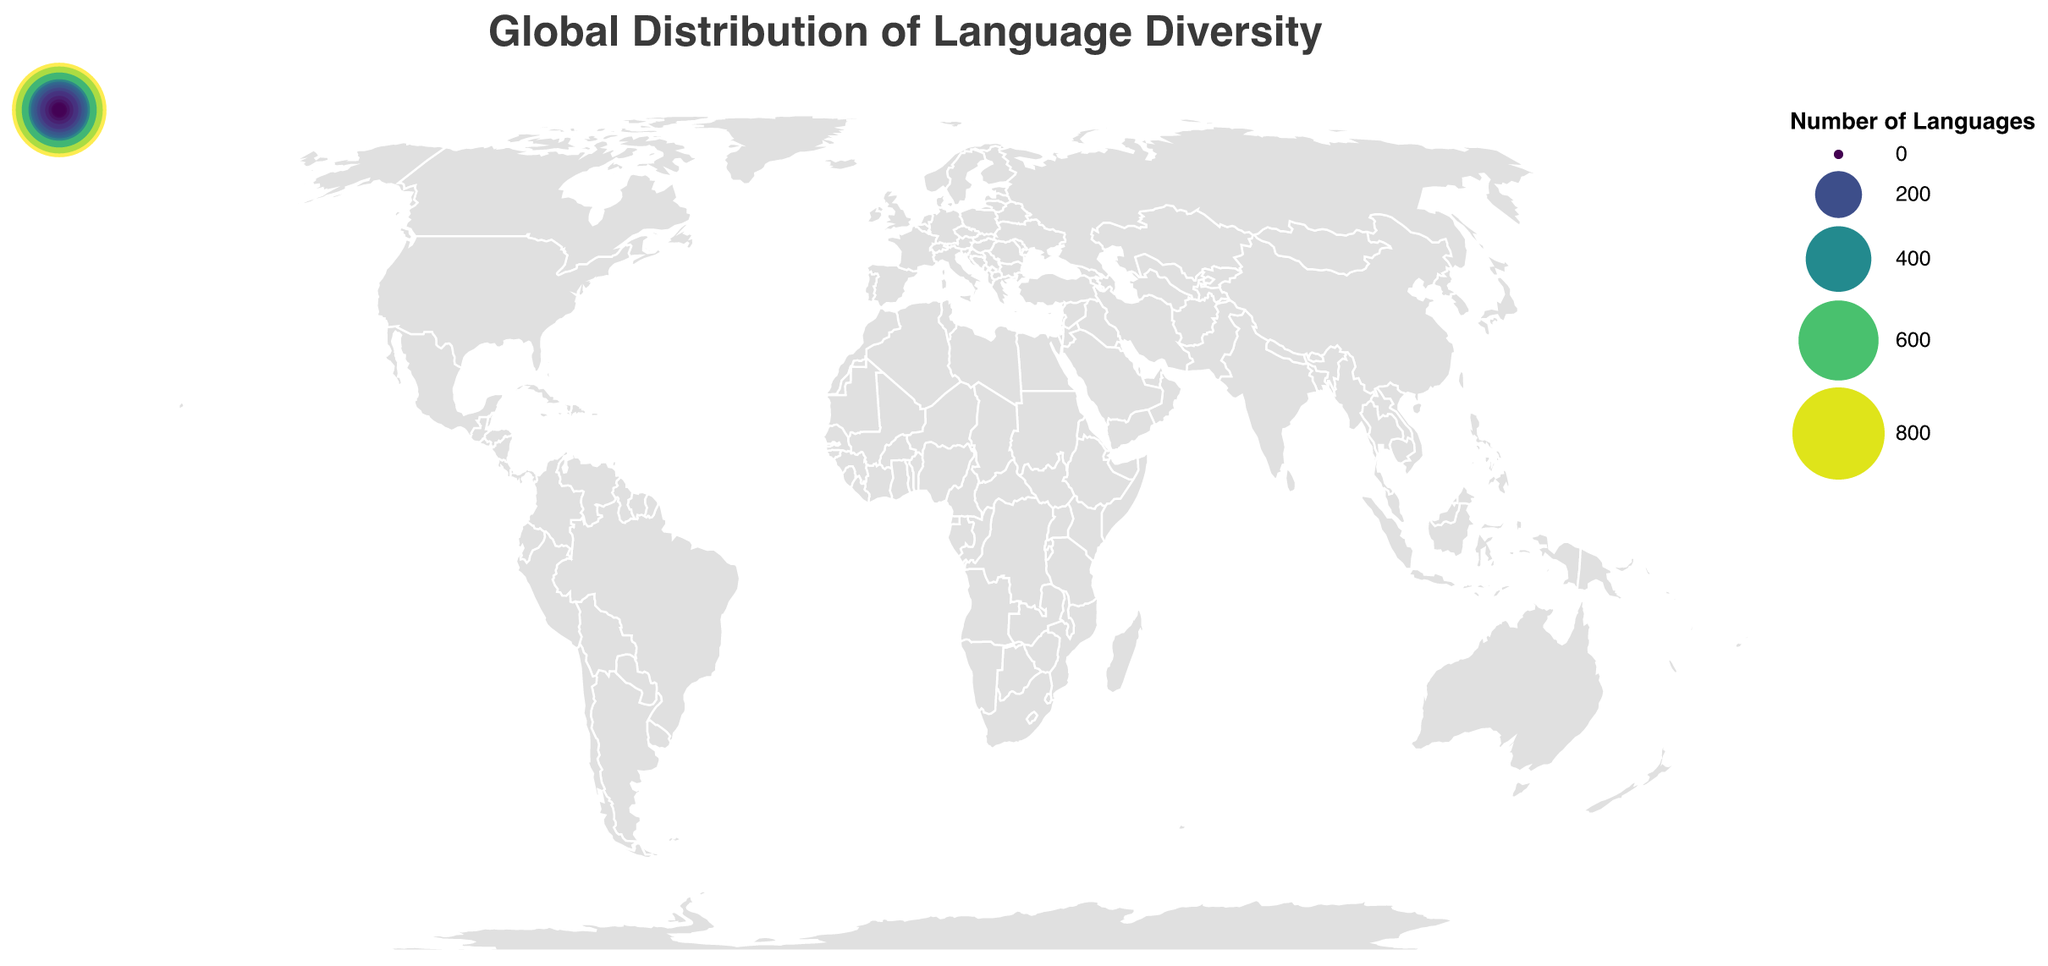Which country has the highest number of languages spoken? The size and color scales in the plot indicate the number of languages spoken. By interpreting the largest and darkest circle, the country with the highest number of languages spoken is identifiable.
Answer: Papua New Guinea What is the title of the plot? The title is often positioned prominently at the top of the plot. It provides a quick summary of what the data visualization represents.
Answer: Global Distribution of Language Diversity How many languages are spoken in the United States? The tooltip feature will display the number of languages spoken for a specific country when hovered over. Identify the United States and read the tooltip.
Answer: 350 Which country has the smallest circle representing the number of languages spoken? The smallest circle, often with a lighter color, indicates the country with the fewest languages spoken.
Answer: Saudi Arabia What is the range of the circle sizes used in the plot? Circle sizes in the plot scale according to the number of languages. The scale range is given in the plot's settings but scaled visually from 20 to 2000.
Answer: 20 to 2000 Provide the names of three countries with fewer than 50 languages spoken. By examining the circles with the smallest sizes and lighter colors, three countries with fewer than 50 languages spoken can be identified.
Answer: South Africa, Japan, United Kingdom, Saudi Arabia Which continent seems to have the highest language diversity based on the countries represented? Observing the concentration and size of circles on each continent, the continent with the most and largest circles indicating higher language diversity can be identified.
Answer: Asia What's the average number of languages spoken in China and India? Sum the number of languages spoken in both countries and then divide by two. (China: 302, India: 447)
Answer: (302 + 447) / 2 = 374.5 Compare the language diversity between Nigeria and Brazil. Which country has more languages spoken? By observing the circle sizes and colors for Nigeria and Brazil, the country with the larger and darker circle has more languages spoken.
Answer: Nigeria Which region (Northern, Southern, Eastern, Western, Central) of Africa has the most language diversity based on the countries shown? Identify the African countries in the plot and compare their geographic positions and the size of the circles. Western Africa (represented by Nigeria and Cameroon) appears to have the most language diversity.
Answer: Western Africa 